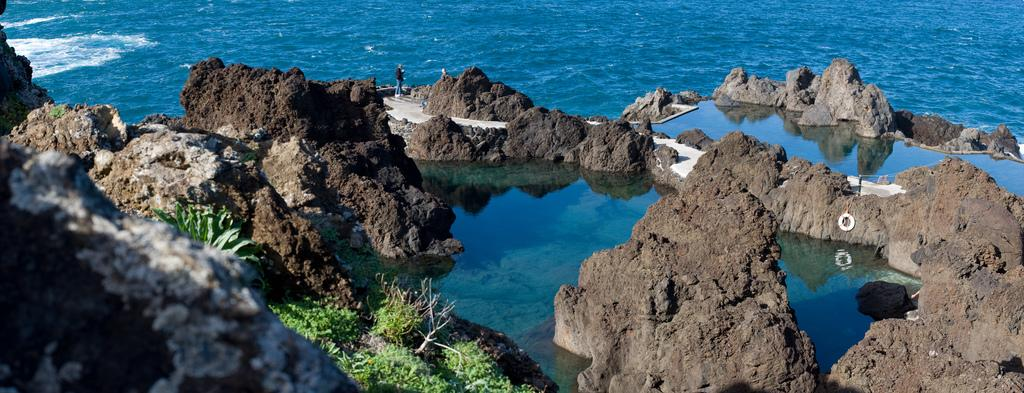Who or what is present in the image? There is a person in the image. What is the primary element visible in the image? Water is visible in the image. What type of natural elements can be seen in the image? Plants and rocks are present in the image. Reasoning: Let's think step by identifying the main subjects and objects in the image based on the provided facts. We then formulate questions that focus on the location and characteristics of these subjects and objects, ensuring that each question can be answered definitively with the information given. We avoid yes/no questions and ensure that the language is simple and clear. Absurd Question/Answer: What type of twig can be seen floating in the water in the image? There is no twig visible in the image; only water, plants, rocks, and a person are present. Can you tell me how many pieces of popcorn are scattered among the plants in the image? There is no popcorn present in the image; only water, plants, rocks, and a person are visible. Are there any icicles hanging from the plants in the image? There are no icicles present in the image; only water, plants, rocks, and a person are visible. 